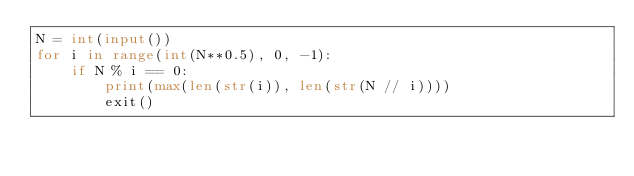<code> <loc_0><loc_0><loc_500><loc_500><_Python_>N = int(input())
for i in range(int(N**0.5), 0, -1):
    if N % i == 0:
        print(max(len(str(i)), len(str(N // i))))
        exit()</code> 